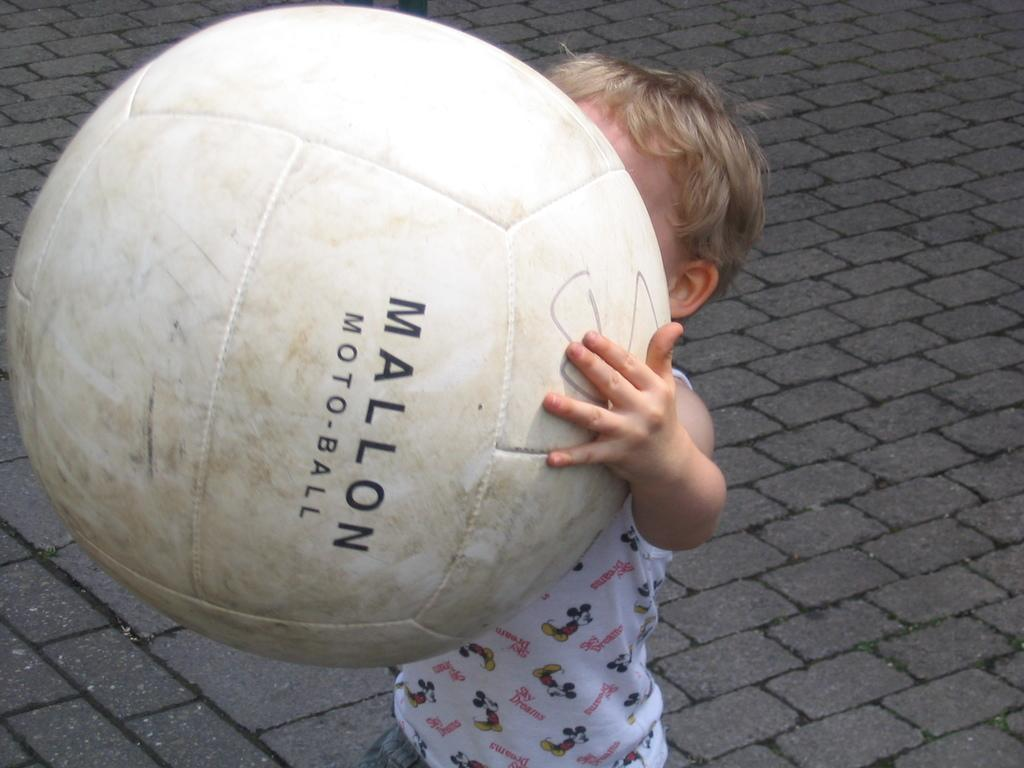What is the main subject of the image? The main subject of the image is a kid. What is the kid wearing in the image? The kid is wearing clothes in the image. What is the kid doing with his hands in the image? The kid is holding another kid with his hands in the image. What type of tray is the governor using to carry the rain in the image? There is no governor, tray, or rain present in the image. 